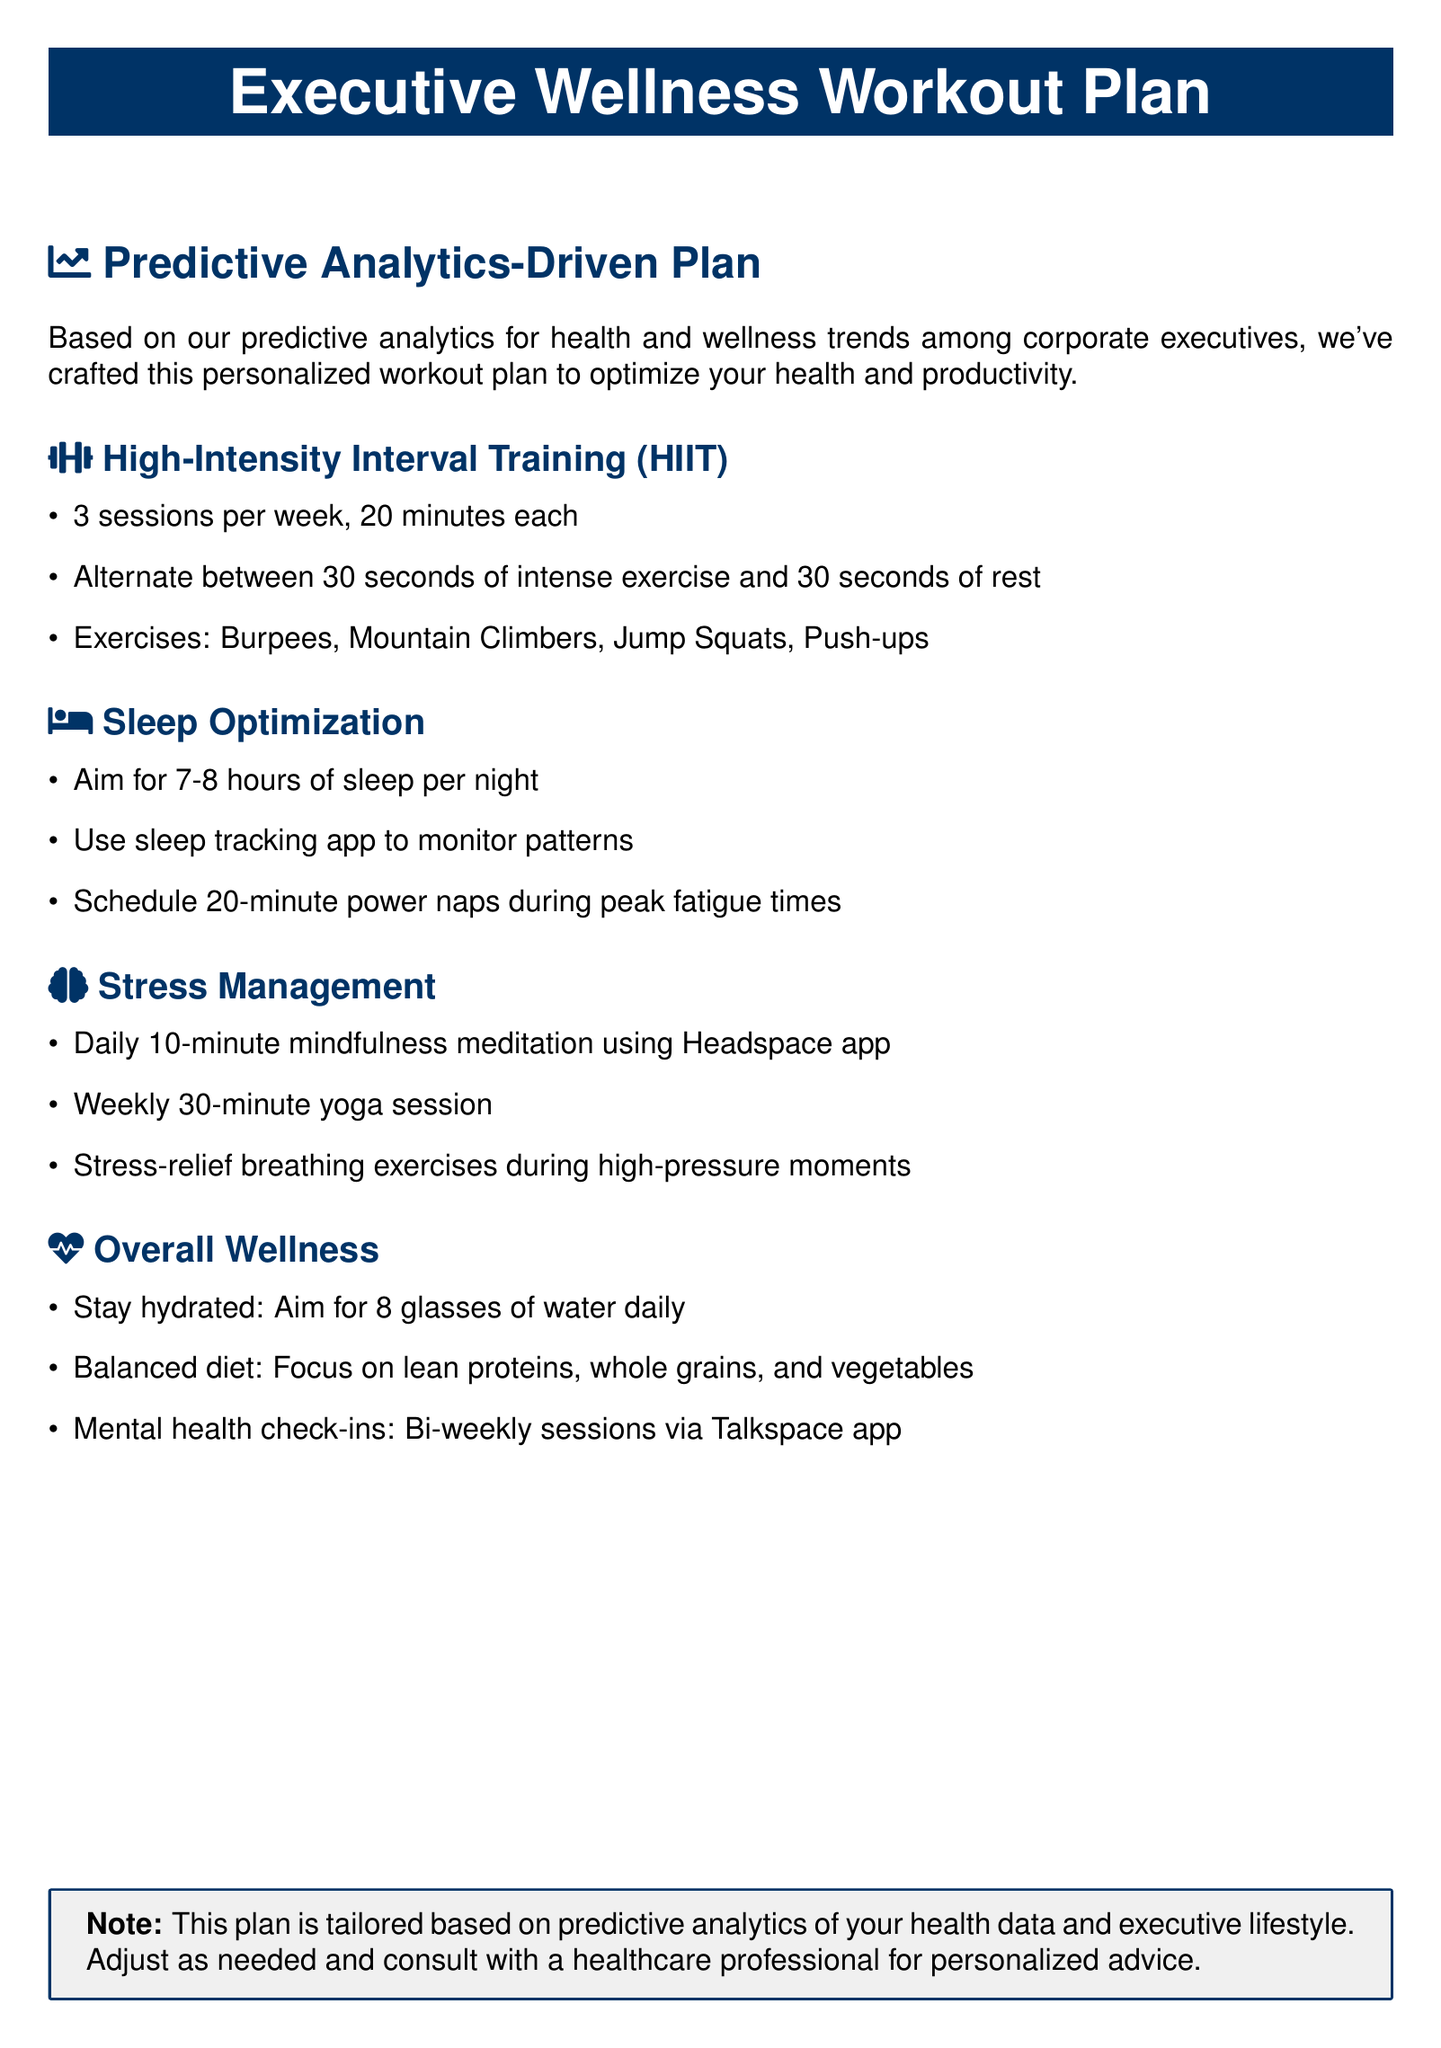What type of training is included in the workout plan? The document specifies High-Intensity Interval Training (HIIT) as the workout type.
Answer: High-Intensity Interval Training (HIIT) How many sessions of HIIT are recommended per week? The document states that it recommends 3 sessions of HIIT per week.
Answer: 3 sessions What is the recommended duration for each HIIT session? The duration for each HIIT session, as indicated in the document, is 20 minutes.
Answer: 20 minutes Which app is suggested for mindfulness meditation? The document mentions the Headspace app for mindfulness meditation.
Answer: Headspace How many hours of sleep should be aimed for each night? The document suggests aiming for 7-8 hours of sleep each night.
Answer: 7-8 hours What is a recommended hydration goal according to the document? The document advises aiming for 8 glasses of water daily for hydration.
Answer: 8 glasses What is the frequency of mental health check-ins recommended? The document states that mental health check-ins should occur bi-weekly.
Answer: Bi-weekly What kind of diet is recommended in the overall wellness section? The document specifies a focus on lean proteins, whole grains, and vegetables for a balanced diet.
Answer: Lean proteins, whole grains, and vegetables What activity is suggested for stress management besides meditation? The document mentions a weekly yoga session as a stress management activity.
Answer: Weekly yoga session 